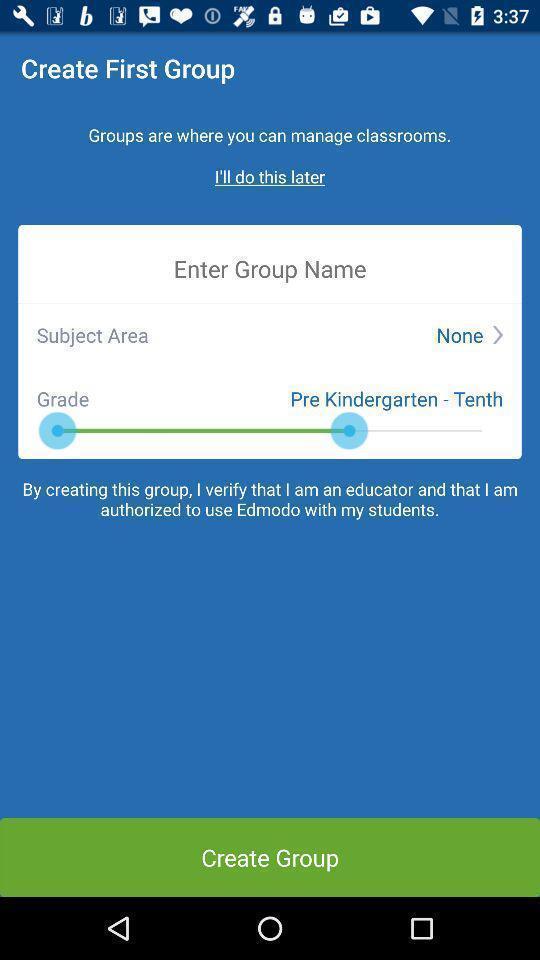Provide a textual representation of this image. Screen shows create option in a teaching app. 